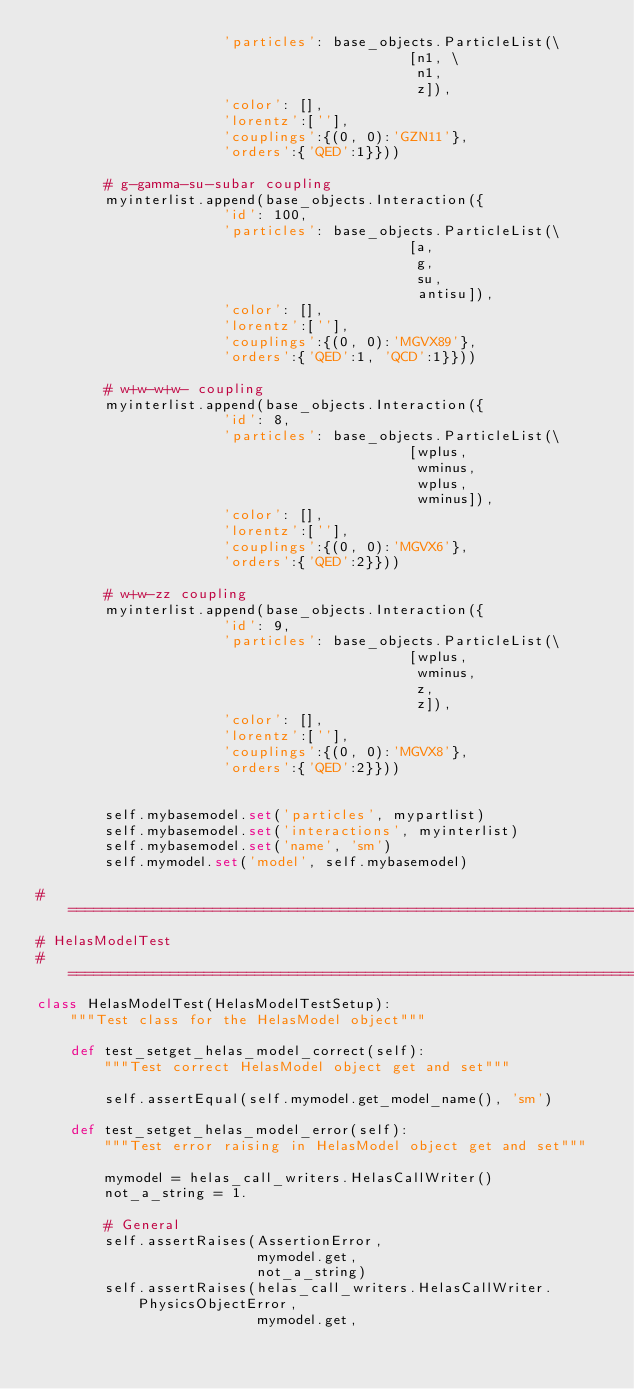Convert code to text. <code><loc_0><loc_0><loc_500><loc_500><_Python_>                      'particles': base_objects.ParticleList(\
                                            [n1, \
                                             n1,
                                             z]),
                      'color': [],
                      'lorentz':[''],
                      'couplings':{(0, 0):'GZN11'},
                      'orders':{'QED':1}}))

        # g-gamma-su-subar coupling
        myinterlist.append(base_objects.Interaction({
                      'id': 100,
                      'particles': base_objects.ParticleList(\
                                            [a,
                                             g,
                                             su,
                                             antisu]),
                      'color': [],
                      'lorentz':[''],
                      'couplings':{(0, 0):'MGVX89'},
                      'orders':{'QED':1, 'QCD':1}}))

        # w+w-w+w- coupling
        myinterlist.append(base_objects.Interaction({
                      'id': 8,
                      'particles': base_objects.ParticleList(\
                                            [wplus,
                                             wminus,
                                             wplus,
                                             wminus]),
                      'color': [],
                      'lorentz':[''],
                      'couplings':{(0, 0):'MGVX6'},
                      'orders':{'QED':2}}))

        # w+w-zz coupling
        myinterlist.append(base_objects.Interaction({
                      'id': 9,
                      'particles': base_objects.ParticleList(\
                                            [wplus,
                                             wminus,
                                             z,
                                             z]),
                      'color': [],
                      'lorentz':[''],
                      'couplings':{(0, 0):'MGVX8'},
                      'orders':{'QED':2}}))


        self.mybasemodel.set('particles', mypartlist)
        self.mybasemodel.set('interactions', myinterlist)
        self.mybasemodel.set('name', 'sm')
        self.mymodel.set('model', self.mybasemodel)

#===============================================================================
# HelasModelTest
#===============================================================================
class HelasModelTest(HelasModelTestSetup):
    """Test class for the HelasModel object"""

    def test_setget_helas_model_correct(self):
        """Test correct HelasModel object get and set"""

        self.assertEqual(self.mymodel.get_model_name(), 'sm')

    def test_setget_helas_model_error(self):
        """Test error raising in HelasModel object get and set"""

        mymodel = helas_call_writers.HelasCallWriter()
        not_a_string = 1.

        # General
        self.assertRaises(AssertionError,
                          mymodel.get,
                          not_a_string)
        self.assertRaises(helas_call_writers.HelasCallWriter.PhysicsObjectError,
                          mymodel.get,</code> 